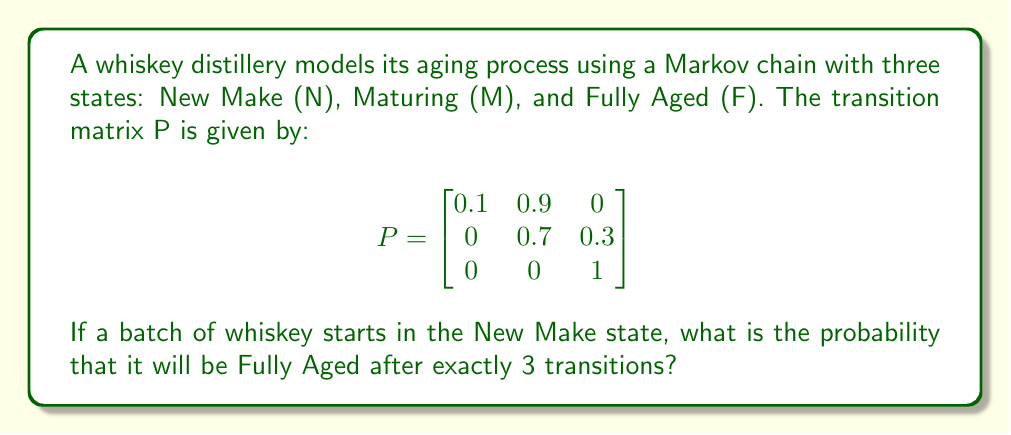What is the answer to this math problem? To solve this problem, we need to calculate the probability of moving from the New Make (N) state to the Fully Aged (F) state in exactly 3 transitions. We can do this by computing $P^3$ and looking at the entry in the first row, third column.

Step 1: Calculate $P^2$
$$P^2 = P \times P = \begin{bmatrix}
0.1 & 0.9 & 0 \\
0 & 0.7 & 0.3 \\
0 & 0 & 1
\end{bmatrix} \times \begin{bmatrix}
0.1 & 0.9 & 0 \\
0 & 0.7 & 0.3 \\
0 & 0 & 1
\end{bmatrix} = \begin{bmatrix}
0.01 & 0.72 & 0.27 \\
0 & 0.49 & 0.51 \\
0 & 0 & 1
\end{bmatrix}$$

Step 2: Calculate $P^3$
$$P^3 = P^2 \times P = \begin{bmatrix}
0.01 & 0.72 & 0.27 \\
0 & 0.49 & 0.51 \\
0 & 0 & 1
\end{bmatrix} \times \begin{bmatrix}
0.1 & 0.9 & 0 \\
0 & 0.7 & 0.3 \\
0 & 0 & 1
\end{bmatrix} = \begin{bmatrix}
0.001 & 0.511 & 0.488 \\
0 & 0.343 & 0.657 \\
0 & 0 & 1
\end{bmatrix}$$

Step 3: Identify the probability
The probability of moving from N to F in exactly 3 transitions is the entry in the first row, third column of $P^3$, which is 0.488.
Answer: 0.488 